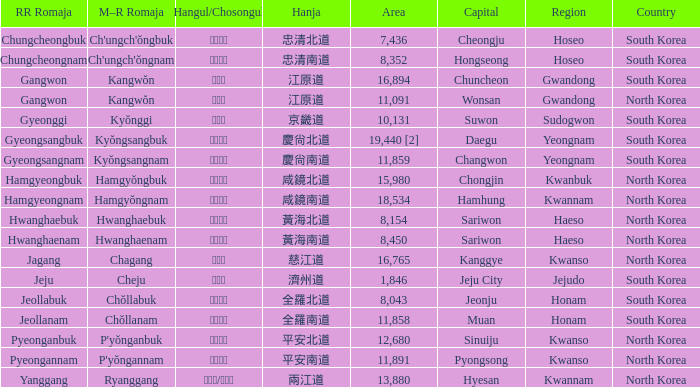What is the RR Romaja for the province that has Hangul of 강원도 and capital of Wonsan? Gangwon. 